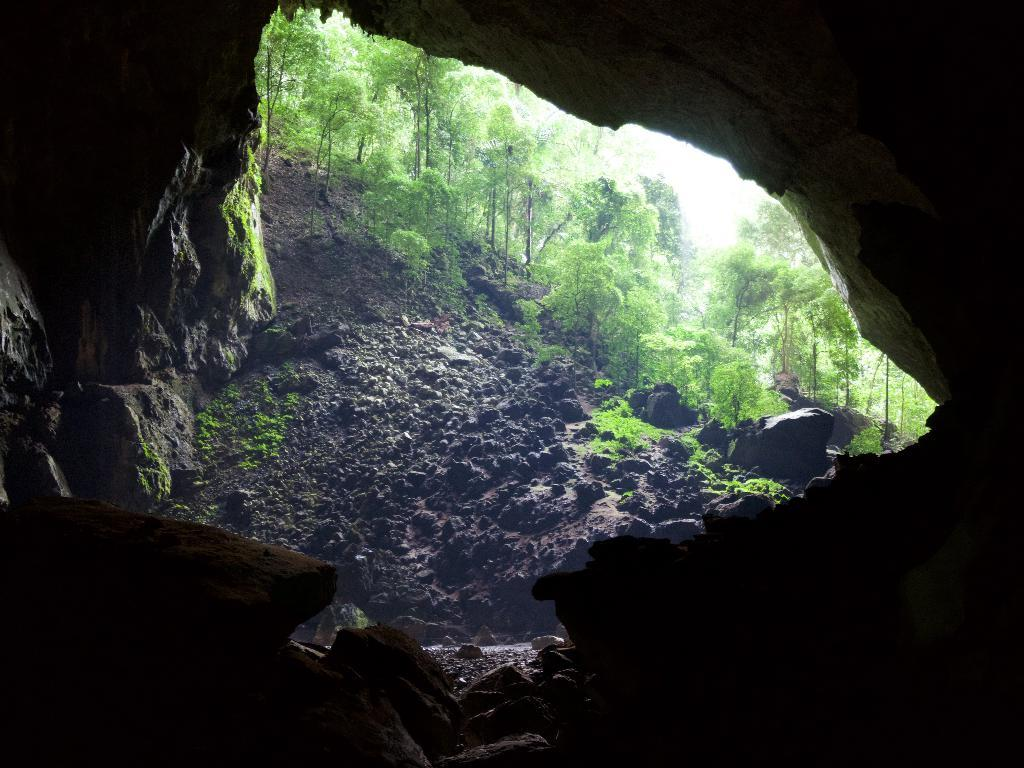What type of natural formation is present in the image? There is a rock cave in the image. What can be seen around the rock cave? Outside the rock cave, there are rocks visible. Is there any indication of a path or trail in the image? Yes, there is a path in the image. What type of vegetation is present in the image? Plants and trees are visible in the image. What country is the rock cave located in, according to the image? The image does not provide any information about the country where the rock cave is located. 